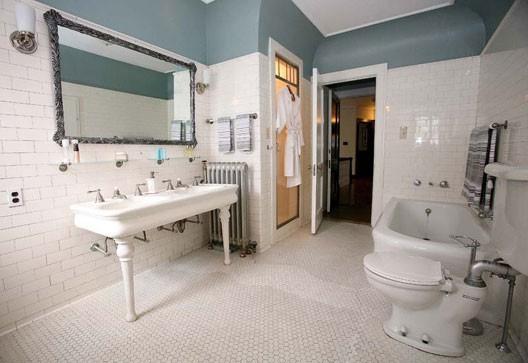What room is this?
Answer briefly. Bathroom. What is on the side of the sink?
Short answer required. Radiator. Is this a kitchen?
Answer briefly. No. What type of flooring is this?
Answer briefly. Tile. 